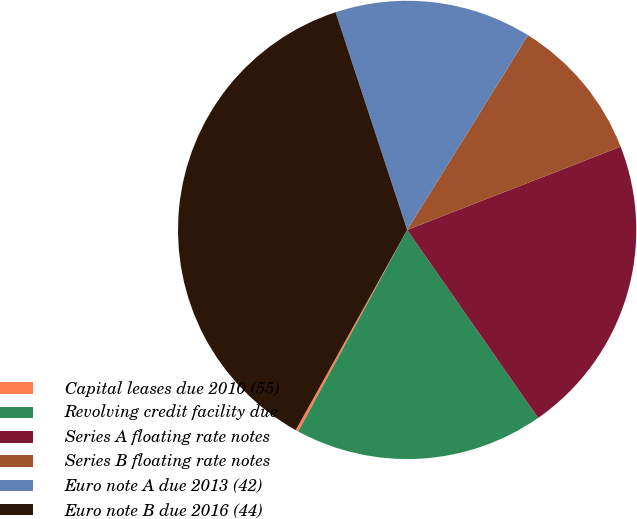<chart> <loc_0><loc_0><loc_500><loc_500><pie_chart><fcel>Capital leases due 2010 (55)<fcel>Revolving credit facility due<fcel>Series A floating rate notes<fcel>Series B floating rate notes<fcel>Euro note A due 2013 (42)<fcel>Euro note B due 2016 (44)<nl><fcel>0.2%<fcel>17.57%<fcel>21.23%<fcel>10.24%<fcel>13.9%<fcel>36.86%<nl></chart> 